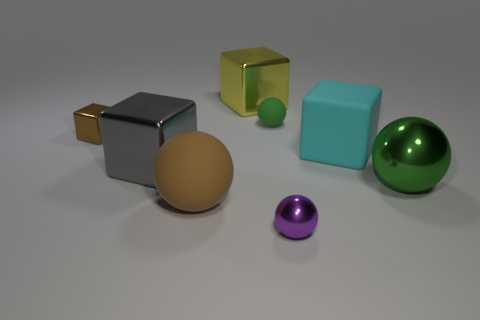Subtract all cyan matte blocks. How many blocks are left? 3 Add 2 matte things. How many objects exist? 10 Subtract all brown balls. How many balls are left? 3 Subtract all blue cubes. How many cyan spheres are left? 0 Subtract all red balls. Subtract all green cylinders. How many balls are left? 4 Subtract all small objects. Subtract all big cyan matte cubes. How many objects are left? 4 Add 7 tiny green matte things. How many tiny green matte things are left? 8 Add 6 red cubes. How many red cubes exist? 6 Subtract 0 green blocks. How many objects are left? 8 